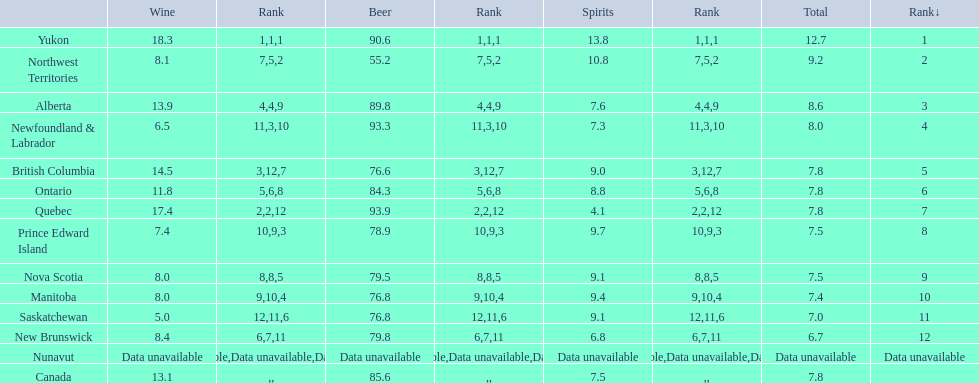Which province consumes the least amount of spirits? Quebec. 